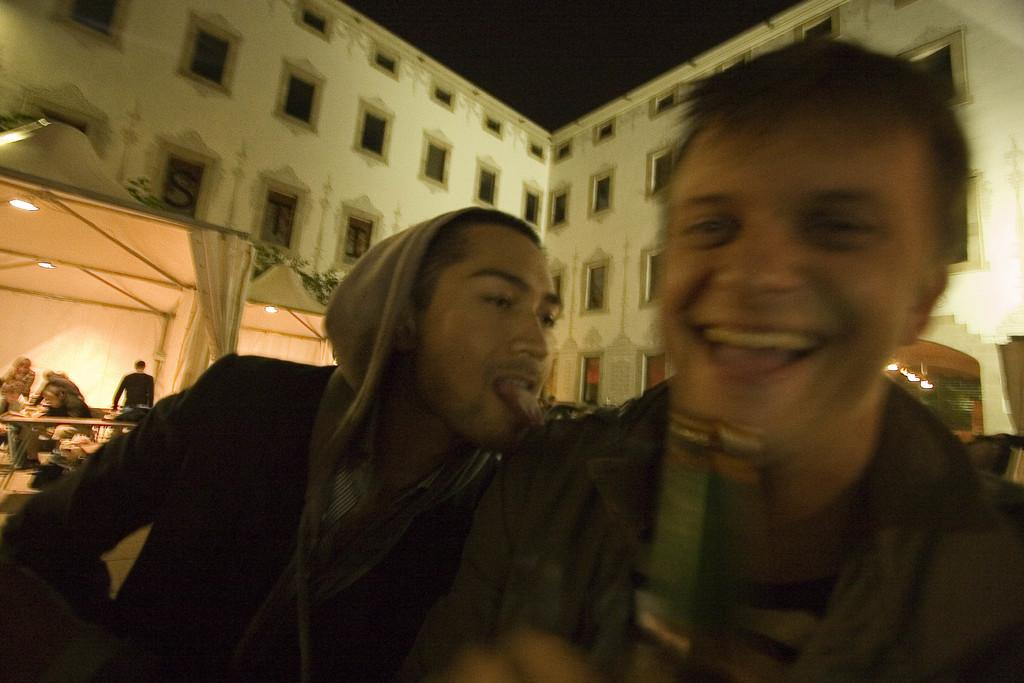How many people are present in the image? There are two persons in the image. Can you describe the background of the image? There are a few people in the background of the image. What type of structure is visible in the image? There is a building with windows in the image. What can be seen illuminated in the image? There are lights visible in the image. What type of sweater is the son wearing in the image? There is no son or sweater present in the image. Can you tell me if the people in the image have received approval for their actions? There is no information about approval or actions in the image. 